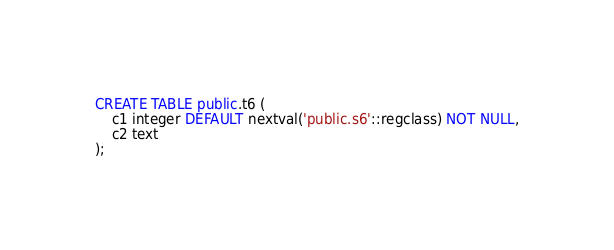<code> <loc_0><loc_0><loc_500><loc_500><_SQL_>CREATE TABLE public.t6 (
    c1 integer DEFAULT nextval('public.s6'::regclass) NOT NULL,
    c2 text
);</code> 